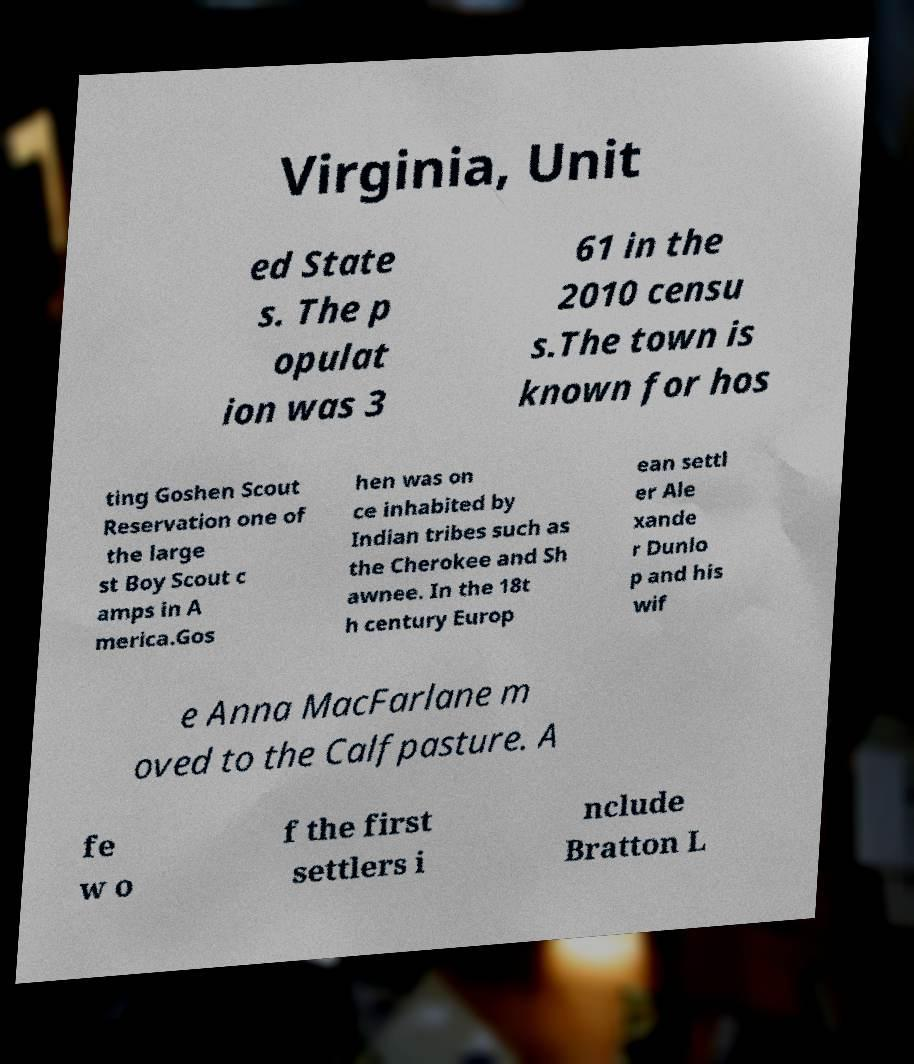Can you read and provide the text displayed in the image?This photo seems to have some interesting text. Can you extract and type it out for me? Virginia, Unit ed State s. The p opulat ion was 3 61 in the 2010 censu s.The town is known for hos ting Goshen Scout Reservation one of the large st Boy Scout c amps in A merica.Gos hen was on ce inhabited by Indian tribes such as the Cherokee and Sh awnee. In the 18t h century Europ ean settl er Ale xande r Dunlo p and his wif e Anna MacFarlane m oved to the Calfpasture. A fe w o f the first settlers i nclude Bratton L 